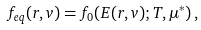<formula> <loc_0><loc_0><loc_500><loc_500>f _ { e q } ( { r } , { v } ) = f _ { 0 } ( E ( { r } , { v } ) ; T , \mu ^ { * } ) \, ,</formula> 